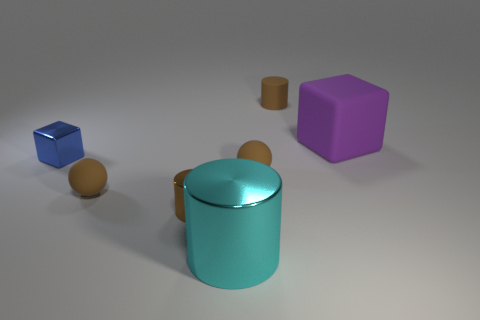Is the size of the brown cylinder that is behind the blue cube the same as the block left of the matte cube?
Your response must be concise. Yes. What shape is the thing that is to the right of the small brown rubber thing behind the big rubber object?
Your answer should be very brief. Cube. How many large cyan things are to the right of the rubber cylinder?
Your response must be concise. 0. The small cylinder that is made of the same material as the purple thing is what color?
Your answer should be very brief. Brown. There is a cyan shiny cylinder; is it the same size as the cylinder behind the tiny blue block?
Give a very brief answer. No. There is a brown object behind the cube in front of the purple block that is right of the large cyan metal cylinder; what is its size?
Your answer should be very brief. Small. What number of matte things are either blue things or tiny cylinders?
Offer a very short reply. 1. What is the color of the matte object that is right of the rubber cylinder?
Ensure brevity in your answer.  Purple. The purple object that is the same size as the cyan metal cylinder is what shape?
Make the answer very short. Cube. There is a rubber cylinder; is its color the same as the large object left of the large purple rubber block?
Offer a terse response. No. 